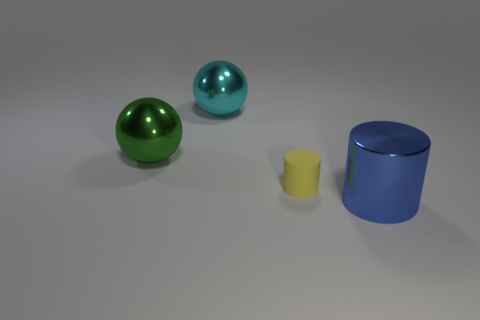What is the color of the sphere that is the same material as the green thing? The sphere that shares the same glossy material qualities as the green sphere is cyan in color, exhibiting a reflective surface that suggests they are both likely made of a similar type of smooth, polished material. 